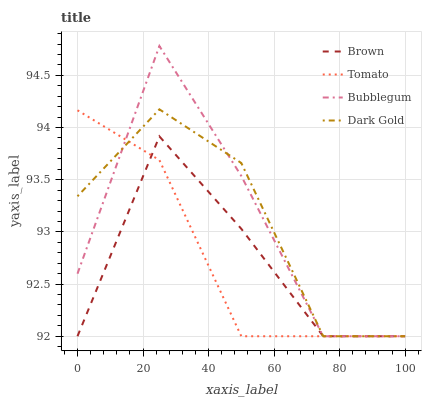Does Tomato have the minimum area under the curve?
Answer yes or no. Yes. Does Bubblegum have the maximum area under the curve?
Answer yes or no. Yes. Does Brown have the minimum area under the curve?
Answer yes or no. No. Does Brown have the maximum area under the curve?
Answer yes or no. No. Is Tomato the smoothest?
Answer yes or no. Yes. Is Bubblegum the roughest?
Answer yes or no. Yes. Is Brown the smoothest?
Answer yes or no. No. Is Brown the roughest?
Answer yes or no. No. Does Tomato have the lowest value?
Answer yes or no. Yes. Does Bubblegum have the highest value?
Answer yes or no. Yes. Does Brown have the highest value?
Answer yes or no. No. Does Bubblegum intersect Dark Gold?
Answer yes or no. Yes. Is Bubblegum less than Dark Gold?
Answer yes or no. No. Is Bubblegum greater than Dark Gold?
Answer yes or no. No. 